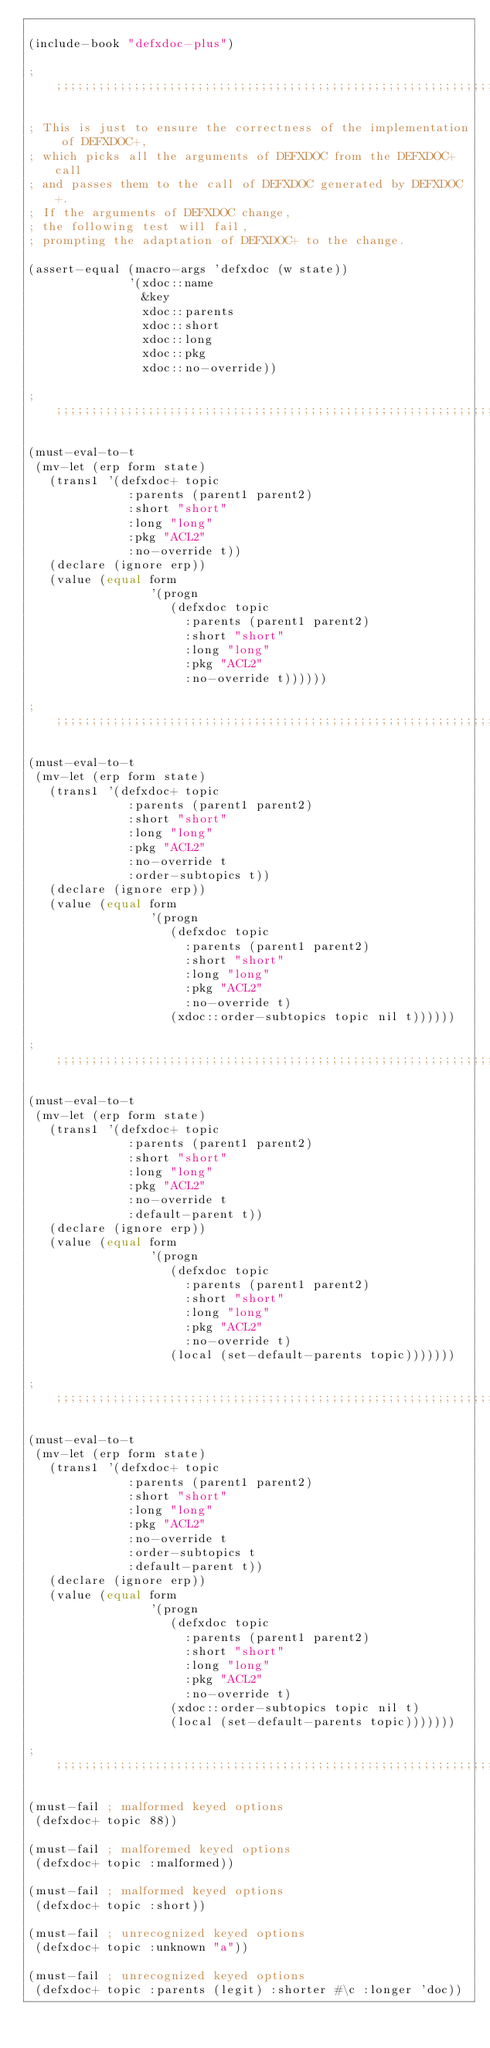Convert code to text. <code><loc_0><loc_0><loc_500><loc_500><_Lisp_>
(include-book "defxdoc-plus")

;;;;;;;;;;;;;;;;;;;;;;;;;;;;;;;;;;;;;;;;;;;;;;;;;;;;;;;;;;;;;;;;;;;;;;;;;;;;;;;;

; This is just to ensure the correctness of the implementation of DEFXDOC+,
; which picks all the arguments of DEFXDOC from the DEFXDOC+ call
; and passes them to the call of DEFXDOC generated by DEFXDOC+.
; If the arguments of DEFXDOC change,
; the following test will fail,
; prompting the adaptation of DEFXDOC+ to the change.

(assert-equal (macro-args 'defxdoc (w state))
              '(xdoc::name
                &key
                xdoc::parents
                xdoc::short
                xdoc::long
                xdoc::pkg
                xdoc::no-override))

;;;;;;;;;;;;;;;;;;;;;;;;;;;;;;;;;;;;;;;;;;;;;;;;;;;;;;;;;;;;;;;;;;;;;;;;;;;;;;;;

(must-eval-to-t
 (mv-let (erp form state)
   (trans1 '(defxdoc+ topic
              :parents (parent1 parent2)
              :short "short"
              :long "long"
              :pkg "ACL2"
              :no-override t))
   (declare (ignore erp))
   (value (equal form
                 '(progn
                    (defxdoc topic
                      :parents (parent1 parent2)
                      :short "short"
                      :long "long"
                      :pkg "ACL2"
                      :no-override t))))))

;;;;;;;;;;;;;;;;;;;;;;;;;;;;;;;;;;;;;;;;;;;;;;;;;;;;;;;;;;;;;;;;;;;;;;;;;;;;;;;;

(must-eval-to-t
 (mv-let (erp form state)
   (trans1 '(defxdoc+ topic
              :parents (parent1 parent2)
              :short "short"
              :long "long"
              :pkg "ACL2"
              :no-override t
              :order-subtopics t))
   (declare (ignore erp))
   (value (equal form
                 '(progn
                    (defxdoc topic
                      :parents (parent1 parent2)
                      :short "short"
                      :long "long"
                      :pkg "ACL2"
                      :no-override t)
                    (xdoc::order-subtopics topic nil t))))))

;;;;;;;;;;;;;;;;;;;;;;;;;;;;;;;;;;;;;;;;;;;;;;;;;;;;;;;;;;;;;;;;;;;;;;;;;;;;;;;;

(must-eval-to-t
 (mv-let (erp form state)
   (trans1 '(defxdoc+ topic
              :parents (parent1 parent2)
              :short "short"
              :long "long"
              :pkg "ACL2"
              :no-override t
              :default-parent t))
   (declare (ignore erp))
   (value (equal form
                 '(progn
                    (defxdoc topic
                      :parents (parent1 parent2)
                      :short "short"
                      :long "long"
                      :pkg "ACL2"
                      :no-override t)
                    (local (set-default-parents topic)))))))

;;;;;;;;;;;;;;;;;;;;;;;;;;;;;;;;;;;;;;;;;;;;;;;;;;;;;;;;;;;;;;;;;;;;;;;;;;;;;;;;

(must-eval-to-t
 (mv-let (erp form state)
   (trans1 '(defxdoc+ topic
              :parents (parent1 parent2)
              :short "short"
              :long "long"
              :pkg "ACL2"
              :no-override t
              :order-subtopics t
              :default-parent t))
   (declare (ignore erp))
   (value (equal form
                 '(progn
                    (defxdoc topic
                      :parents (parent1 parent2)
                      :short "short"
                      :long "long"
                      :pkg "ACL2"
                      :no-override t)
                    (xdoc::order-subtopics topic nil t)
                    (local (set-default-parents topic)))))))

;;;;;;;;;;;;;;;;;;;;;;;;;;;;;;;;;;;;;;;;;;;;;;;;;;;;;;;;;;;;;;;;;;;;;;;;;;;;;;;;

(must-fail ; malformed keyed options
 (defxdoc+ topic 88))

(must-fail ; malforemed keyed options
 (defxdoc+ topic :malformed))

(must-fail ; malformed keyed options
 (defxdoc+ topic :short))

(must-fail ; unrecognized keyed options
 (defxdoc+ topic :unknown "a"))

(must-fail ; unrecognized keyed options
 (defxdoc+ topic :parents (legit) :shorter #\c :longer 'doc))
</code> 